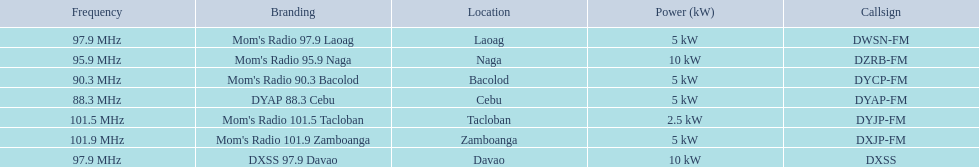What are all of the frequencies? 97.9 MHz, 95.9 MHz, 90.3 MHz, 88.3 MHz, 101.5 MHz, 101.9 MHz, 97.9 MHz. Could you parse the entire table? {'header': ['Frequency', 'Branding', 'Location', 'Power (kW)', 'Callsign'], 'rows': [['97.9\xa0MHz', "Mom's Radio 97.9 Laoag", 'Laoag', '5\xa0kW', 'DWSN-FM'], ['95.9\xa0MHz', "Mom's Radio 95.9 Naga", 'Naga', '10\xa0kW', 'DZRB-FM'], ['90.3\xa0MHz', "Mom's Radio 90.3 Bacolod", 'Bacolod', '5\xa0kW', 'DYCP-FM'], ['88.3\xa0MHz', 'DYAP 88.3 Cebu', 'Cebu', '5\xa0kW', 'DYAP-FM'], ['101.5\xa0MHz', "Mom's Radio 101.5 Tacloban", 'Tacloban', '2.5\xa0kW', 'DYJP-FM'], ['101.9\xa0MHz', "Mom's Radio 101.9 Zamboanga", 'Zamboanga', '5\xa0kW', 'DXJP-FM'], ['97.9\xa0MHz', 'DXSS 97.9 Davao', 'Davao', '10\xa0kW', 'DXSS']]} Which of these frequencies is the lowest? 88.3 MHz. Which branding does this frequency belong to? DYAP 88.3 Cebu. 